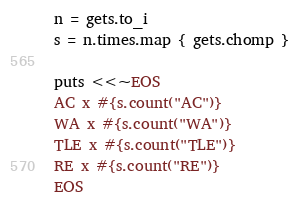Convert code to text. <code><loc_0><loc_0><loc_500><loc_500><_Ruby_>n = gets.to_i
s = n.times.map { gets.chomp }

puts <<~EOS
AC x #{s.count("AC")}
WA x #{s.count("WA")}
TLE x #{s.count("TLE")}
RE x #{s.count("RE")}
EOS</code> 